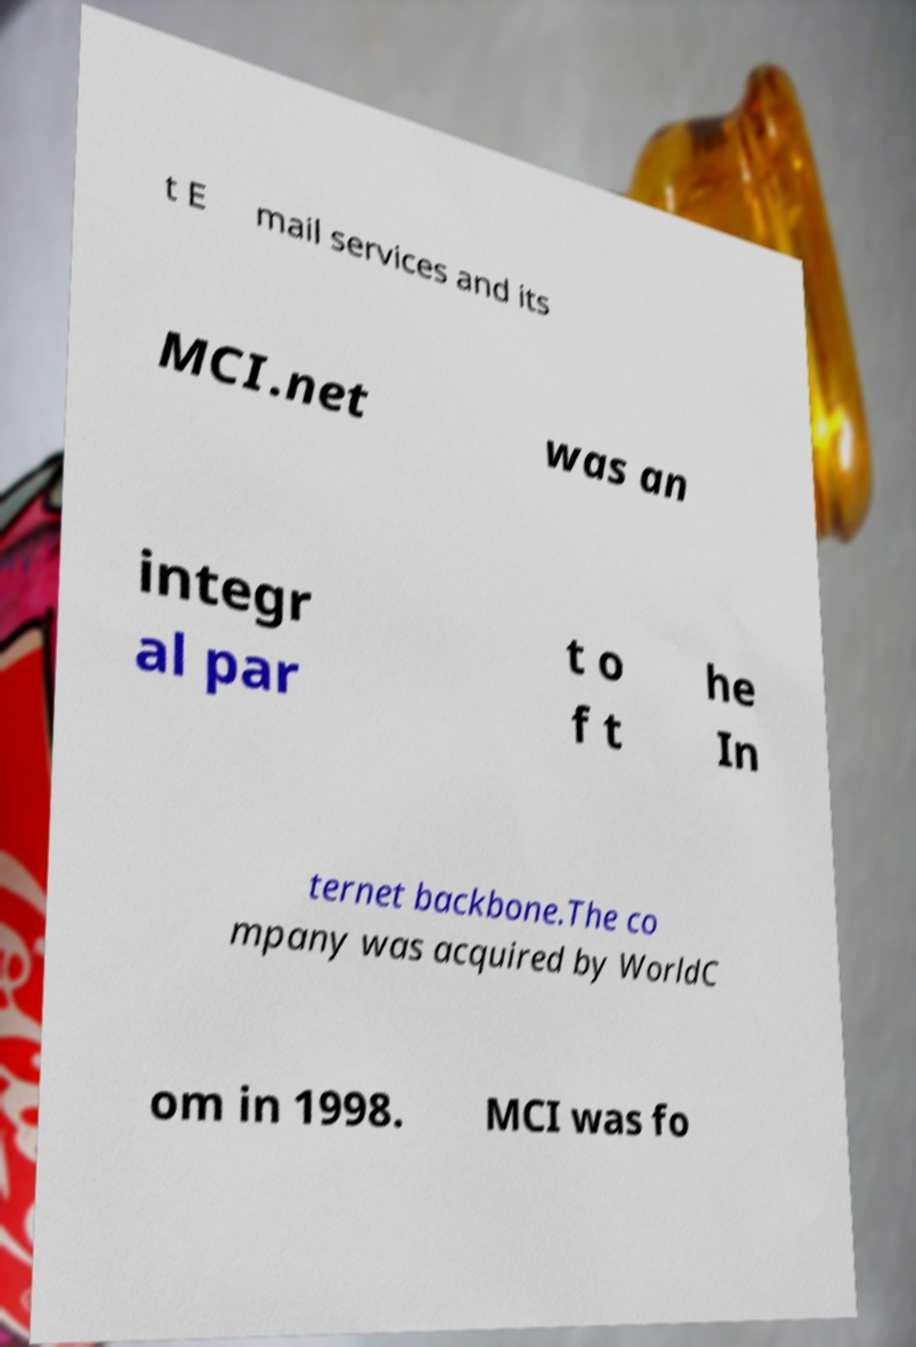Can you read and provide the text displayed in the image?This photo seems to have some interesting text. Can you extract and type it out for me? t E mail services and its MCI.net was an integr al par t o f t he In ternet backbone.The co mpany was acquired by WorldC om in 1998. MCI was fo 